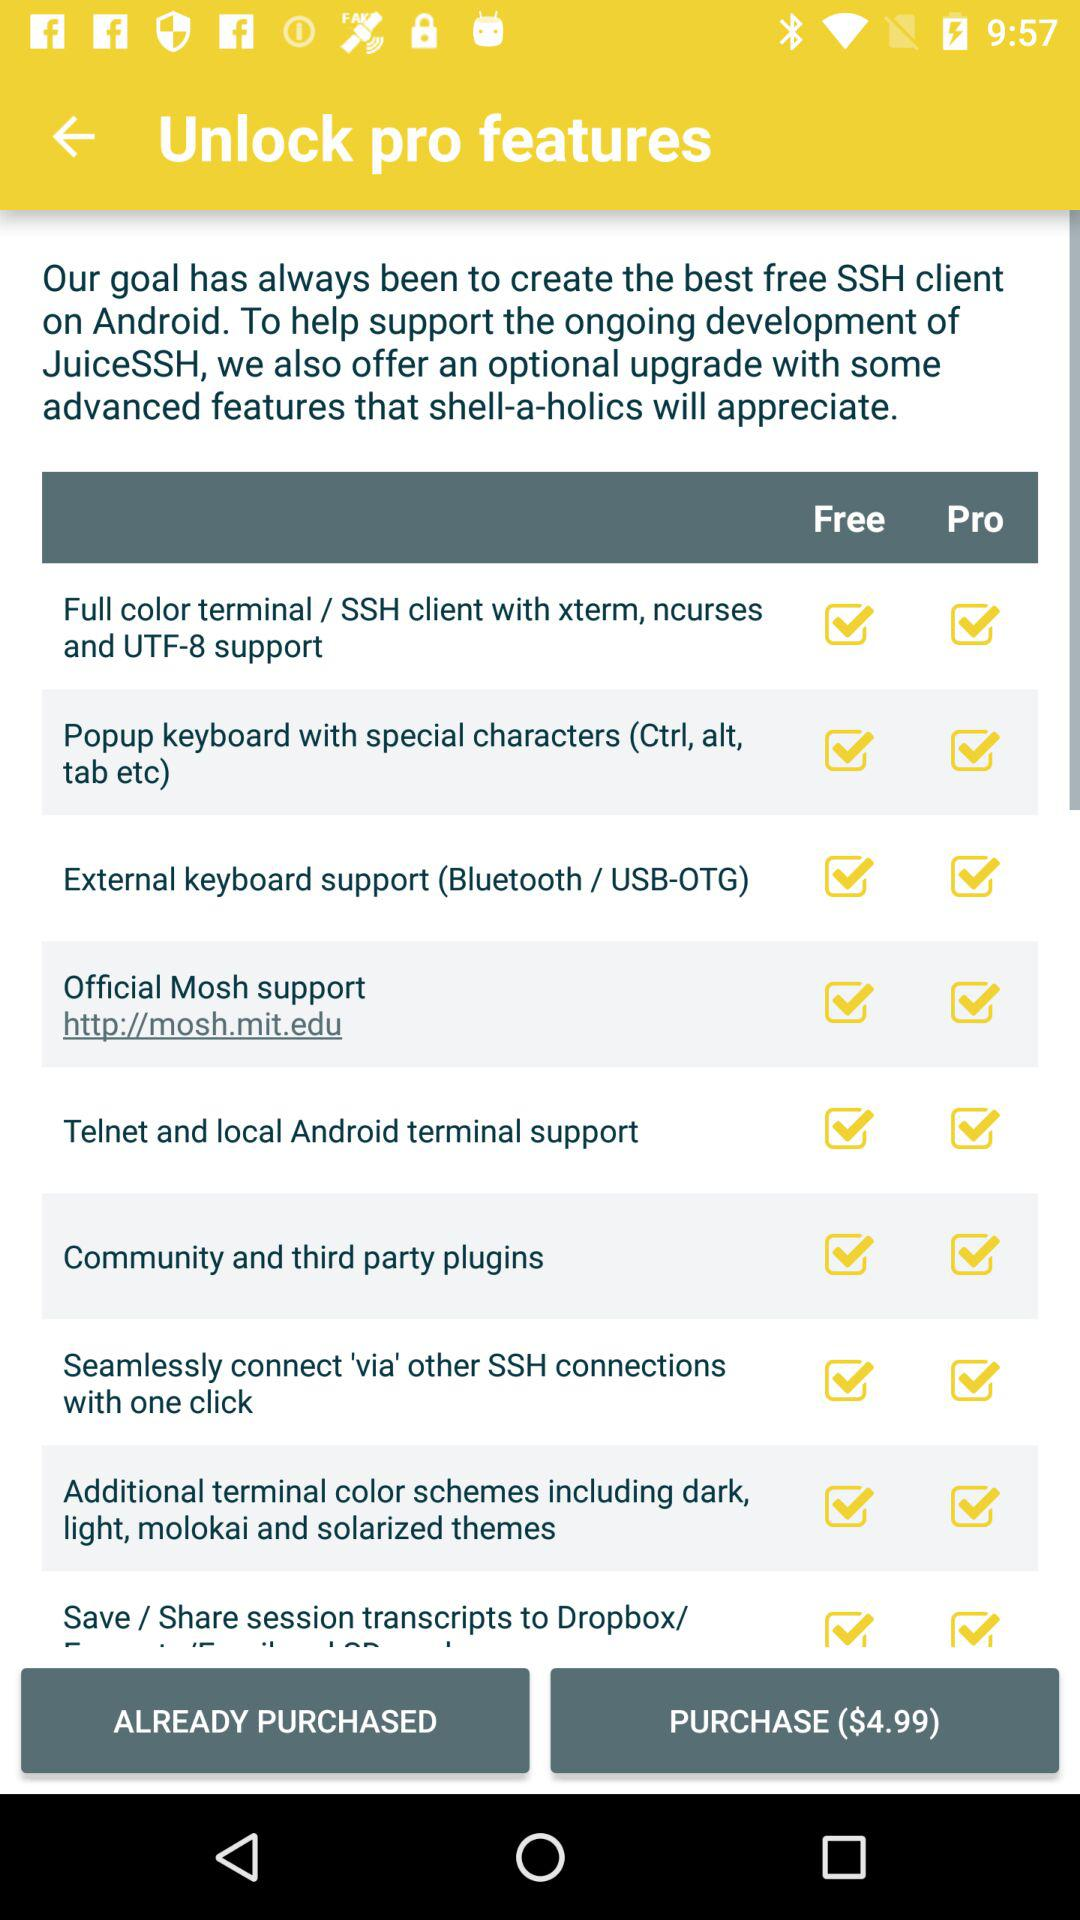Is telnet and local android terminal support pro or unpro?
When the provided information is insufficient, respond with <no answer>. <no answer> 